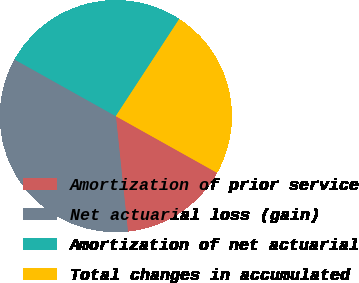Convert chart to OTSL. <chart><loc_0><loc_0><loc_500><loc_500><pie_chart><fcel>Amortization of prior service<fcel>Net actuarial loss (gain)<fcel>Amortization of net actuarial<fcel>Total changes in accumulated<nl><fcel>15.22%<fcel>34.78%<fcel>26.09%<fcel>23.91%<nl></chart> 